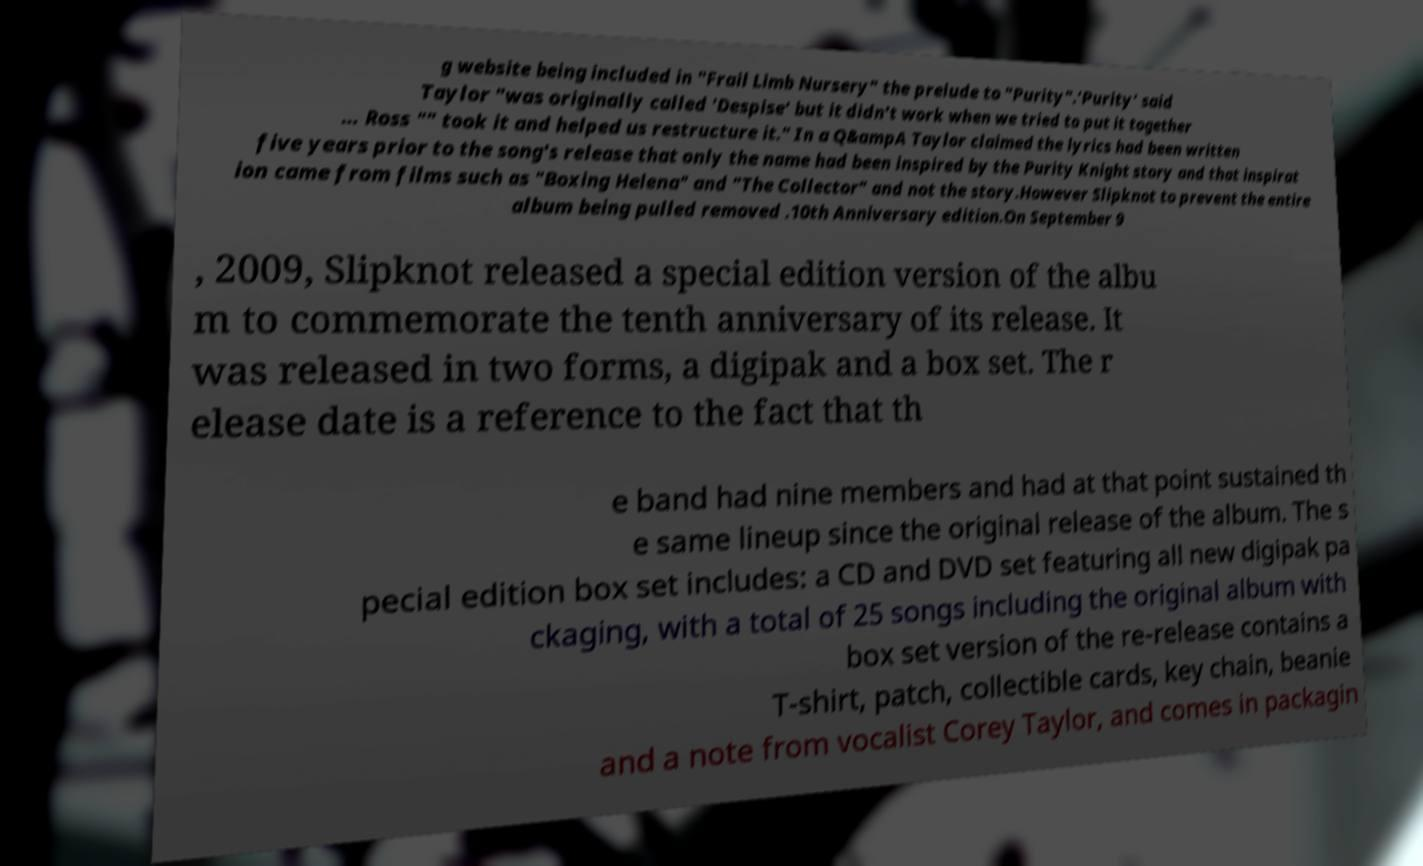Please identify and transcribe the text found in this image. g website being included in "Frail Limb Nursery" the prelude to "Purity".'Purity' said Taylor "was originally called 'Despise' but it didn't work when we tried to put it together … Ross "" took it and helped us restructure it." In a Q&ampA Taylor claimed the lyrics had been written five years prior to the song's release that only the name had been inspired by the Purity Knight story and that inspirat ion came from films such as "Boxing Helena" and "The Collector" and not the story.However Slipknot to prevent the entire album being pulled removed .10th Anniversary edition.On September 9 , 2009, Slipknot released a special edition version of the albu m to commemorate the tenth anniversary of its release. It was released in two forms, a digipak and a box set. The r elease date is a reference to the fact that th e band had nine members and had at that point sustained th e same lineup since the original release of the album. The s pecial edition box set includes: a CD and DVD set featuring all new digipak pa ckaging, with a total of 25 songs including the original album with box set version of the re-release contains a T-shirt, patch, collectible cards, key chain, beanie and a note from vocalist Corey Taylor, and comes in packagin 